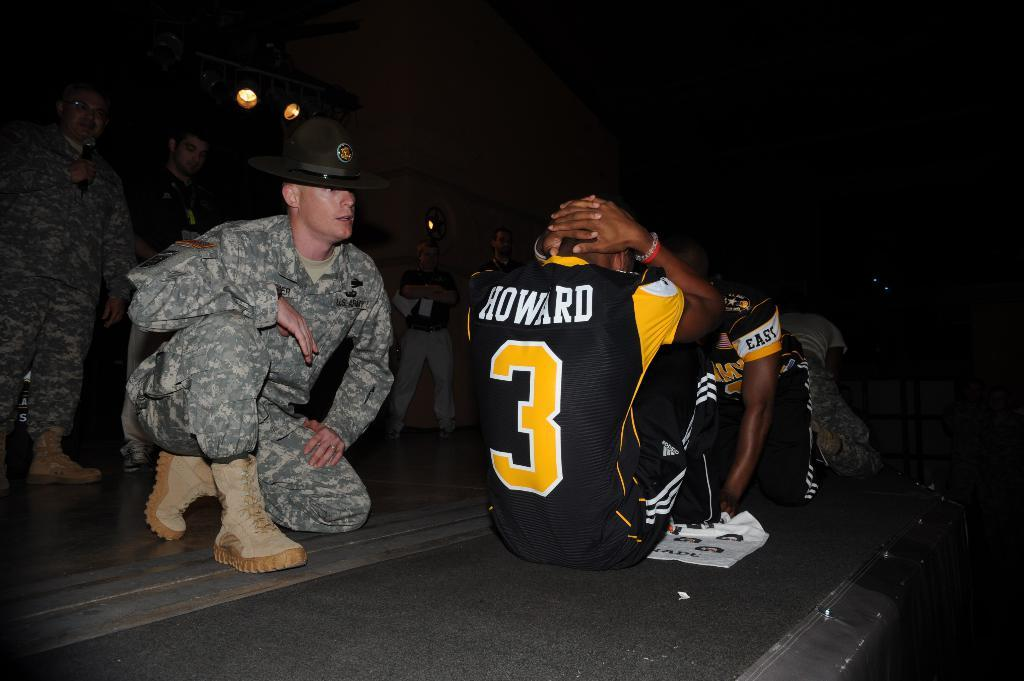<image>
Render a clear and concise summary of the photo. A marine makes two sportsmen exercise one of whom is wearing the number 3 and the name Howard. 